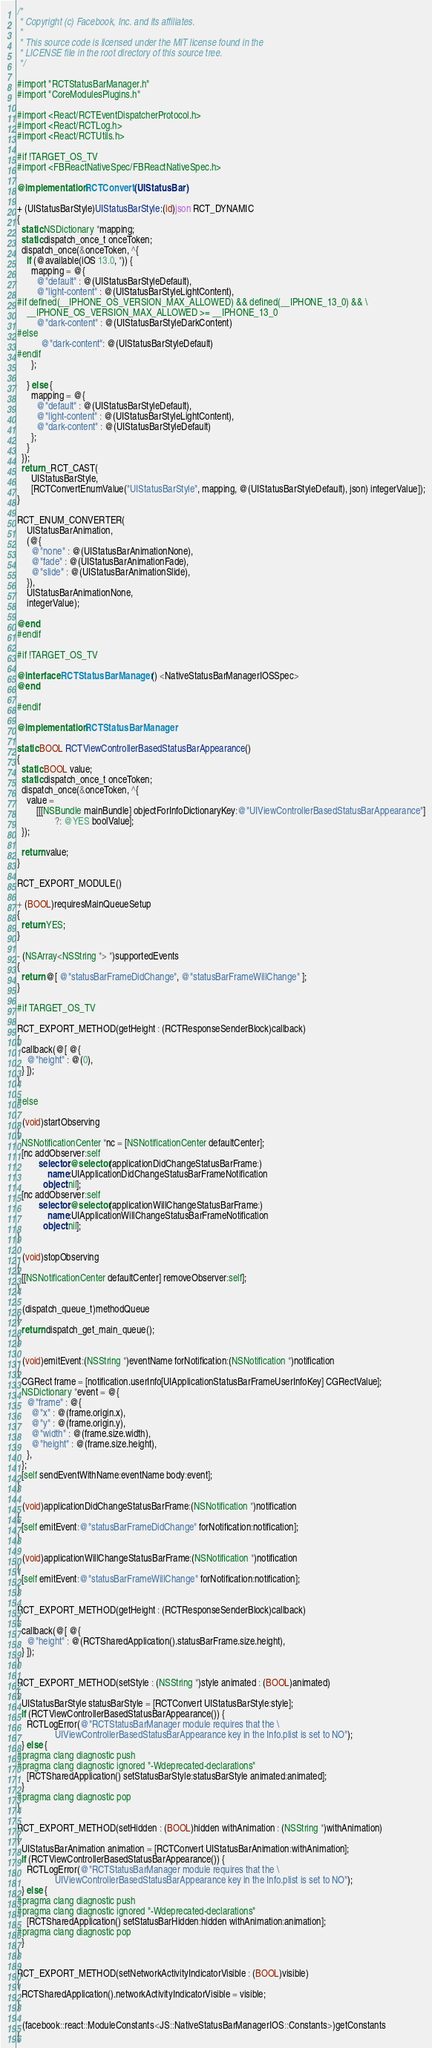<code> <loc_0><loc_0><loc_500><loc_500><_ObjectiveC_>/*
 * Copyright (c) Facebook, Inc. and its affiliates.
 *
 * This source code is licensed under the MIT license found in the
 * LICENSE file in the root directory of this source tree.
 */

#import "RCTStatusBarManager.h"
#import "CoreModulesPlugins.h"

#import <React/RCTEventDispatcherProtocol.h>
#import <React/RCTLog.h>
#import <React/RCTUtils.h>

#if !TARGET_OS_TV
#import <FBReactNativeSpec/FBReactNativeSpec.h>

@implementation RCTConvert (UIStatusBar)

+ (UIStatusBarStyle)UIStatusBarStyle:(id)json RCT_DYNAMIC
{
  static NSDictionary *mapping;
  static dispatch_once_t onceToken;
  dispatch_once(&onceToken, ^{
    if (@available(iOS 13.0, *)) {
      mapping = @{
        @"default" : @(UIStatusBarStyleDefault),
        @"light-content" : @(UIStatusBarStyleLightContent),
#if defined(__IPHONE_OS_VERSION_MAX_ALLOWED) && defined(__IPHONE_13_0) && \
    __IPHONE_OS_VERSION_MAX_ALLOWED >= __IPHONE_13_0
        @"dark-content" : @(UIStatusBarStyleDarkContent)
#else
          @"dark-content": @(UIStatusBarStyleDefault)
#endif
      };

    } else {
      mapping = @{
        @"default" : @(UIStatusBarStyleDefault),
        @"light-content" : @(UIStatusBarStyleLightContent),
        @"dark-content" : @(UIStatusBarStyleDefault)
      };
    }
  });
  return _RCT_CAST(
      UIStatusBarStyle,
      [RCTConvertEnumValue("UIStatusBarStyle", mapping, @(UIStatusBarStyleDefault), json) integerValue]);
}

RCT_ENUM_CONVERTER(
    UIStatusBarAnimation,
    (@{
      @"none" : @(UIStatusBarAnimationNone),
      @"fade" : @(UIStatusBarAnimationFade),
      @"slide" : @(UIStatusBarAnimationSlide),
    }),
    UIStatusBarAnimationNone,
    integerValue);

@end
#endif

#if !TARGET_OS_TV

@interface RCTStatusBarManager () <NativeStatusBarManagerIOSSpec>
@end

#endif

@implementation RCTStatusBarManager

static BOOL RCTViewControllerBasedStatusBarAppearance()
{
  static BOOL value;
  static dispatch_once_t onceToken;
  dispatch_once(&onceToken, ^{
    value =
        [[[NSBundle mainBundle] objectForInfoDictionaryKey:@"UIViewControllerBasedStatusBarAppearance"]
                ?: @YES boolValue];
  });

  return value;
}

RCT_EXPORT_MODULE()

+ (BOOL)requiresMainQueueSetup
{
  return YES;
}

- (NSArray<NSString *> *)supportedEvents
{
  return @[ @"statusBarFrameDidChange", @"statusBarFrameWillChange" ];
}

#if TARGET_OS_TV

RCT_EXPORT_METHOD(getHeight : (RCTResponseSenderBlock)callback)
{
  callback(@[ @{
    @"height" : @(0),
  } ]);
}

#else

- (void)startObserving
{
  NSNotificationCenter *nc = [NSNotificationCenter defaultCenter];
  [nc addObserver:self
         selector:@selector(applicationDidChangeStatusBarFrame:)
             name:UIApplicationDidChangeStatusBarFrameNotification
           object:nil];
  [nc addObserver:self
         selector:@selector(applicationWillChangeStatusBarFrame:)
             name:UIApplicationWillChangeStatusBarFrameNotification
           object:nil];
}

- (void)stopObserving
{
  [[NSNotificationCenter defaultCenter] removeObserver:self];
}

- (dispatch_queue_t)methodQueue
{
  return dispatch_get_main_queue();
}

- (void)emitEvent:(NSString *)eventName forNotification:(NSNotification *)notification
{
  CGRect frame = [notification.userInfo[UIApplicationStatusBarFrameUserInfoKey] CGRectValue];
  NSDictionary *event = @{
    @"frame" : @{
      @"x" : @(frame.origin.x),
      @"y" : @(frame.origin.y),
      @"width" : @(frame.size.width),
      @"height" : @(frame.size.height),
    },
  };
  [self sendEventWithName:eventName body:event];
}

- (void)applicationDidChangeStatusBarFrame:(NSNotification *)notification
{
  [self emitEvent:@"statusBarFrameDidChange" forNotification:notification];
}

- (void)applicationWillChangeStatusBarFrame:(NSNotification *)notification
{
  [self emitEvent:@"statusBarFrameWillChange" forNotification:notification];
}

RCT_EXPORT_METHOD(getHeight : (RCTResponseSenderBlock)callback)
{
  callback(@[ @{
    @"height" : @(RCTSharedApplication().statusBarFrame.size.height),
  } ]);
}

RCT_EXPORT_METHOD(setStyle : (NSString *)style animated : (BOOL)animated)
{
  UIStatusBarStyle statusBarStyle = [RCTConvert UIStatusBarStyle:style];
  if (RCTViewControllerBasedStatusBarAppearance()) {
    RCTLogError(@"RCTStatusBarManager module requires that the \
                UIViewControllerBasedStatusBarAppearance key in the Info.plist is set to NO");
  } else {
#pragma clang diagnostic push
#pragma clang diagnostic ignored "-Wdeprecated-declarations"
    [RCTSharedApplication() setStatusBarStyle:statusBarStyle animated:animated];
  }
#pragma clang diagnostic pop
}

RCT_EXPORT_METHOD(setHidden : (BOOL)hidden withAnimation : (NSString *)withAnimation)
{
  UIStatusBarAnimation animation = [RCTConvert UIStatusBarAnimation:withAnimation];
  if (RCTViewControllerBasedStatusBarAppearance()) {
    RCTLogError(@"RCTStatusBarManager module requires that the \
                UIViewControllerBasedStatusBarAppearance key in the Info.plist is set to NO");
  } else {
#pragma clang diagnostic push
#pragma clang diagnostic ignored "-Wdeprecated-declarations"
    [RCTSharedApplication() setStatusBarHidden:hidden withAnimation:animation];
#pragma clang diagnostic pop
  }
}

RCT_EXPORT_METHOD(setNetworkActivityIndicatorVisible : (BOOL)visible)
{
  RCTSharedApplication().networkActivityIndicatorVisible = visible;
}

- (facebook::react::ModuleConstants<JS::NativeStatusBarManagerIOS::Constants>)getConstants
{</code> 